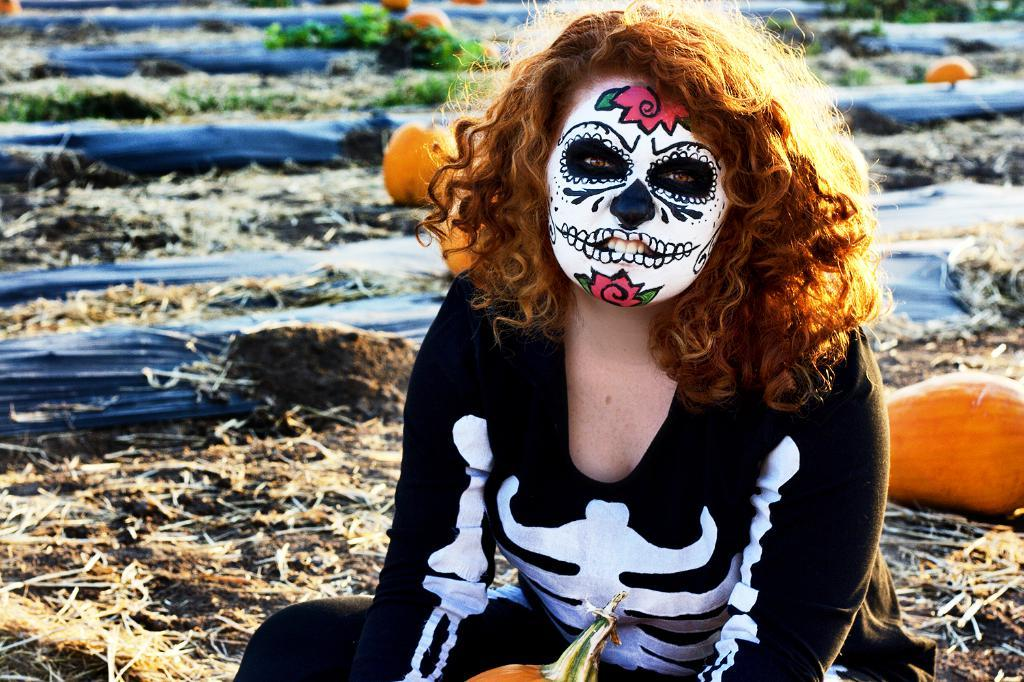Who is the main subject in the image? There is a woman in the image. What is unique about the woman's appearance? The woman has a painting on her face. What type of natural environment is visible in the background of the image? There is dried grass, plants, and pumpkins in the background of the image. Can you describe the unspecified objects in the background? Unfortunately, the facts provided do not specify the nature of the unspecified objects in the background. Is it raining in the image? There is no mention of rain in the image, so we cannot determine if it is raining or not. Can you see a ghost in the image? There is no mention of a ghost in the image, so we cannot determine if one is present or not. 